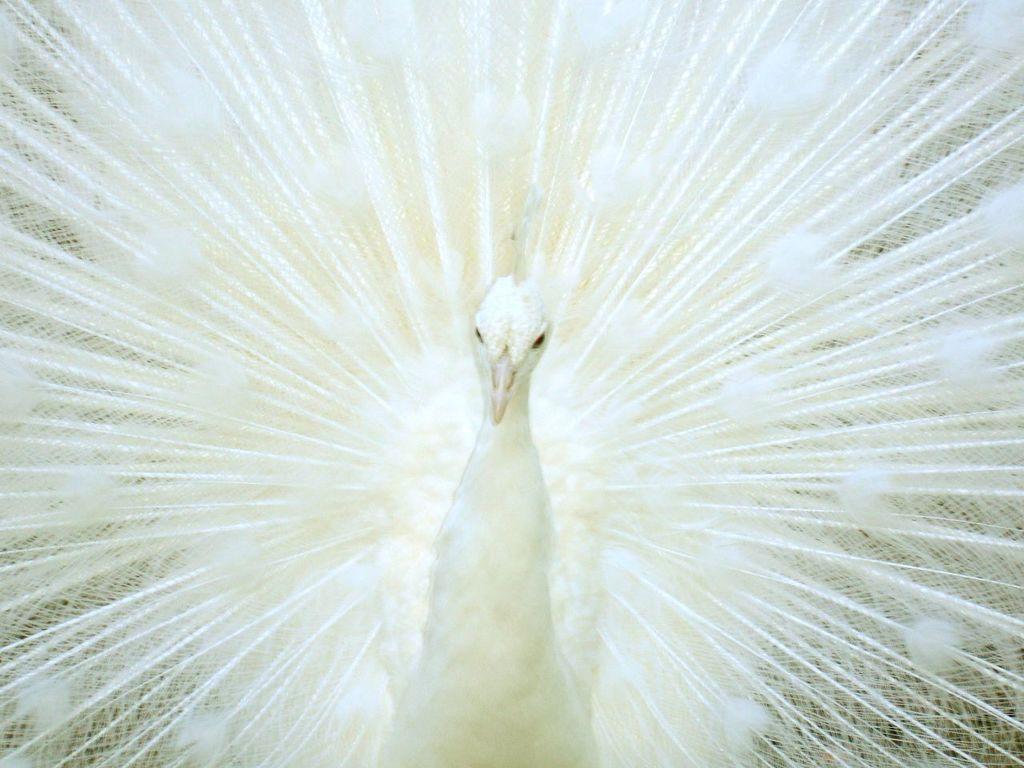Can you describe this image briefly? In this picture we can see a beautiful view of the close white peacock with feathers. 